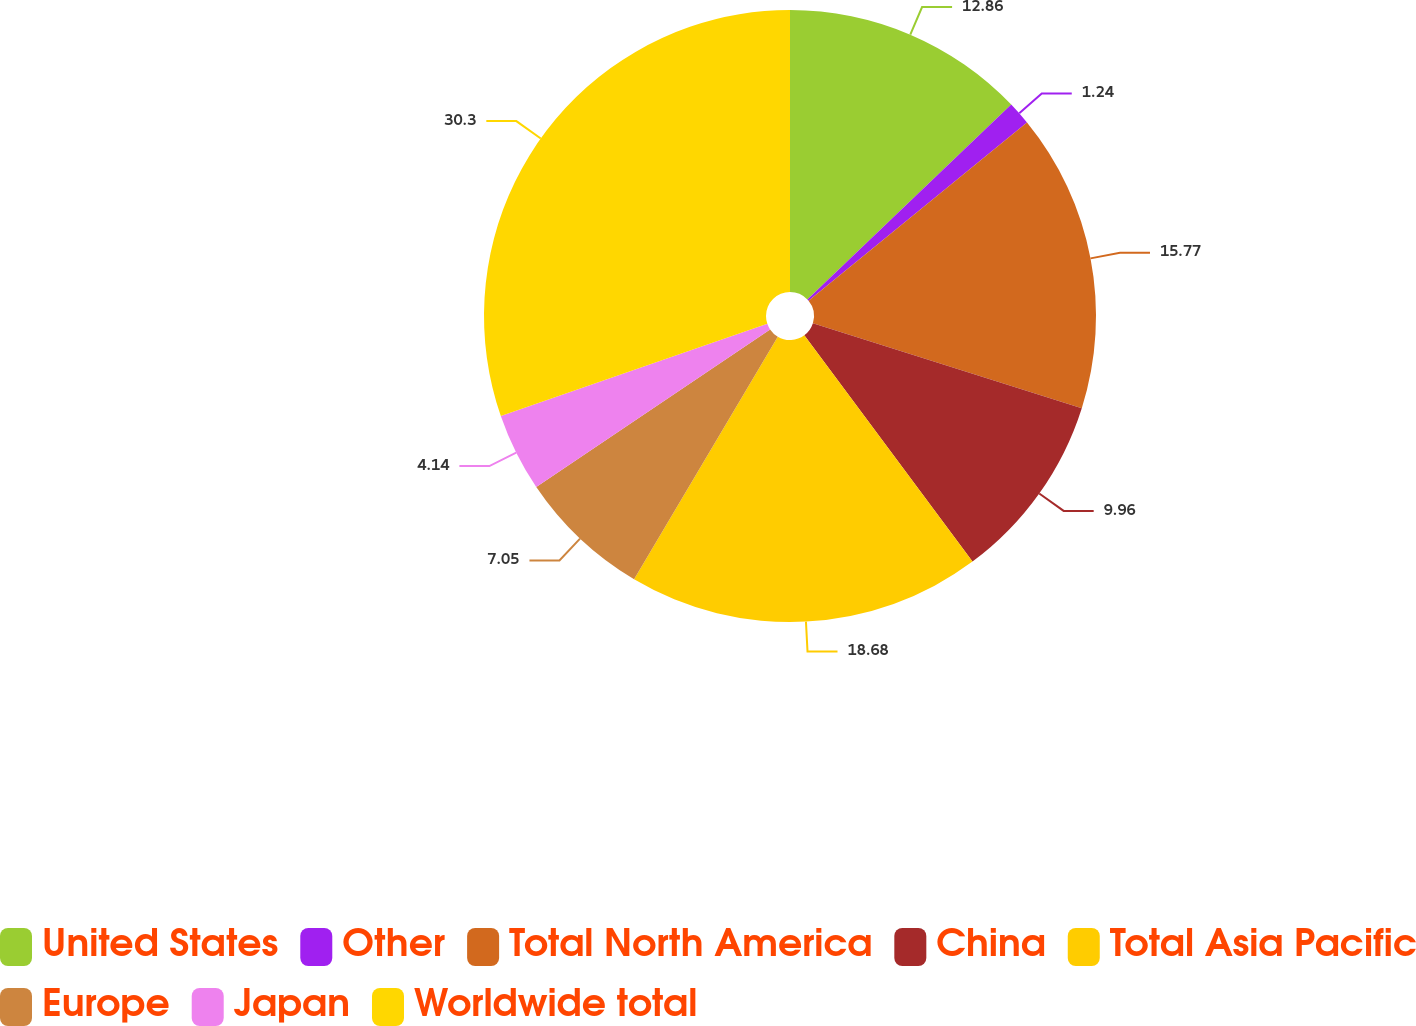Convert chart. <chart><loc_0><loc_0><loc_500><loc_500><pie_chart><fcel>United States<fcel>Other<fcel>Total North America<fcel>China<fcel>Total Asia Pacific<fcel>Europe<fcel>Japan<fcel>Worldwide total<nl><fcel>12.86%<fcel>1.24%<fcel>15.77%<fcel>9.96%<fcel>18.68%<fcel>7.05%<fcel>4.14%<fcel>30.3%<nl></chart> 